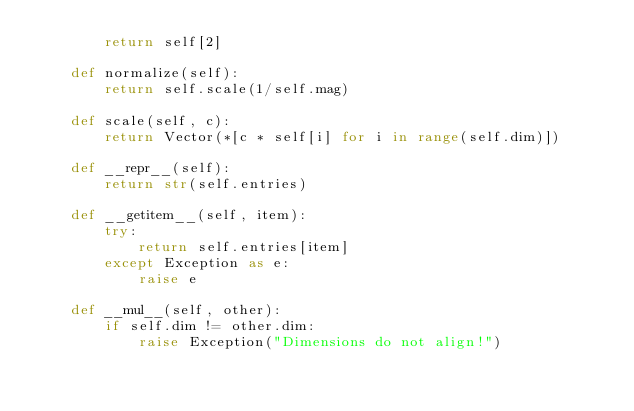<code> <loc_0><loc_0><loc_500><loc_500><_Python_>        return self[2]

    def normalize(self):
        return self.scale(1/self.mag)

    def scale(self, c):
        return Vector(*[c * self[i] for i in range(self.dim)])

    def __repr__(self):
        return str(self.entries)

    def __getitem__(self, item):
        try:
            return self.entries[item]
        except Exception as e:
            raise e

    def __mul__(self, other):
        if self.dim != other.dim:
            raise Exception("Dimensions do not align!")</code> 